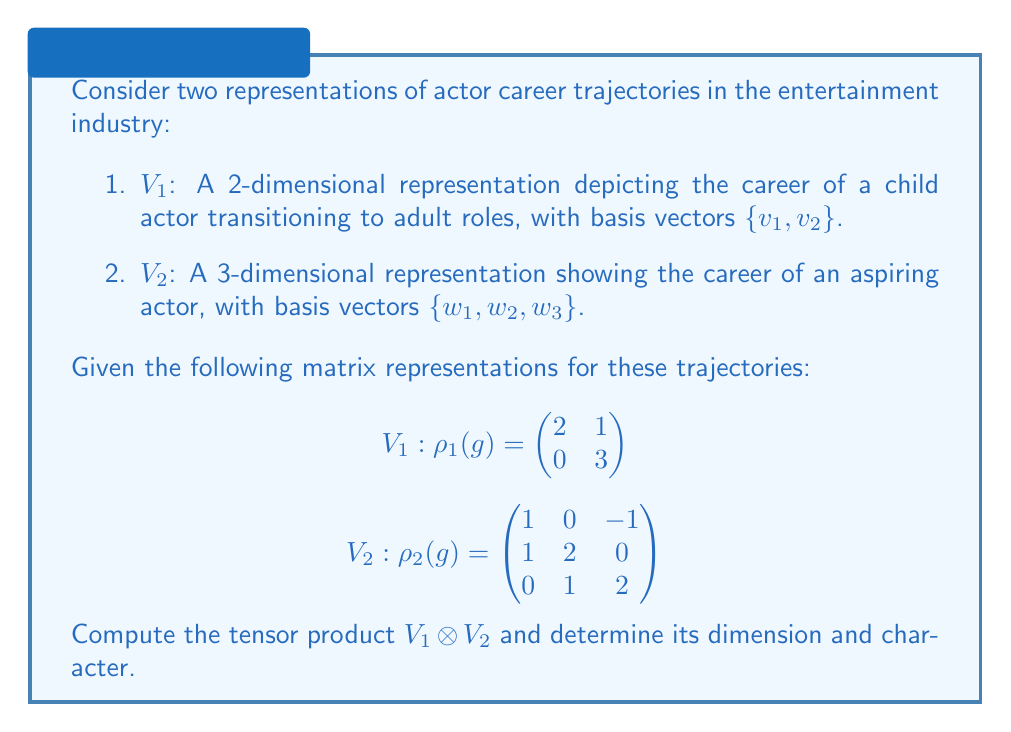Can you solve this math problem? To solve this problem, we'll follow these steps:

1. Determine the dimension of $V_1 \otimes V_2$:
   The dimension of a tensor product is the product of the dimensions of the individual spaces.
   $\dim(V_1 \otimes V_2) = \dim(V_1) \cdot \dim(V_2) = 2 \cdot 3 = 6$

2. Construct the matrix representation of $V_1 \otimes V_2$:
   The tensor product of matrices is given by the Kronecker product:
   
   $$\rho_1(g) \otimes \rho_2(g) = \begin{pmatrix}
   2 \begin{pmatrix} 1 & 0 & -1 \\ 1 & 2 & 0 \\ 0 & 1 & 2 \end{pmatrix} & 
   1 \begin{pmatrix} 1 & 0 & -1 \\ 1 & 2 & 0 \\ 0 & 1 & 2 \end{pmatrix} \\
   0 \begin{pmatrix} 1 & 0 & -1 \\ 1 & 2 & 0 \\ 0 & 1 & 2 \end{pmatrix} & 
   3 \begin{pmatrix} 1 & 0 & -1 \\ 1 & 2 & 0 \\ 0 & 1 & 2 \end{pmatrix}
   \end{pmatrix}$$

   This results in a 6x6 matrix:
   
   $$\rho_1(g) \otimes \rho_2(g) = \begin{pmatrix}
   2 & 0 & -2 & 1 & 0 & -1 \\
   2 & 4 & 0 & 1 & 2 & 0 \\
   0 & 2 & 4 & 0 & 1 & 2 \\
   0 & 0 & 0 & 3 & 0 & -3 \\
   0 & 0 & 0 & 3 & 6 & 0 \\
   0 & 0 & 0 & 0 & 3 & 6
   \end{pmatrix}$$

3. Calculate the character of $V_1 \otimes V_2$:
   The character is the trace of the matrix representation.
   $\chi_{V_1 \otimes V_2}(g) = \text{Tr}(\rho_1(g) \otimes \rho_2(g)) = 2 + 4 + 4 + 3 + 6 + 6 = 25$

This tensor product representation combines the career trajectories of the child actor transitioning to adult roles with that of an aspiring actor, creating a more complex 6-dimensional representation of potential career paths in the entertainment industry.
Answer: $\dim(V_1 \otimes V_2) = 6$, $\chi_{V_1 \otimes V_2}(g) = 25$ 